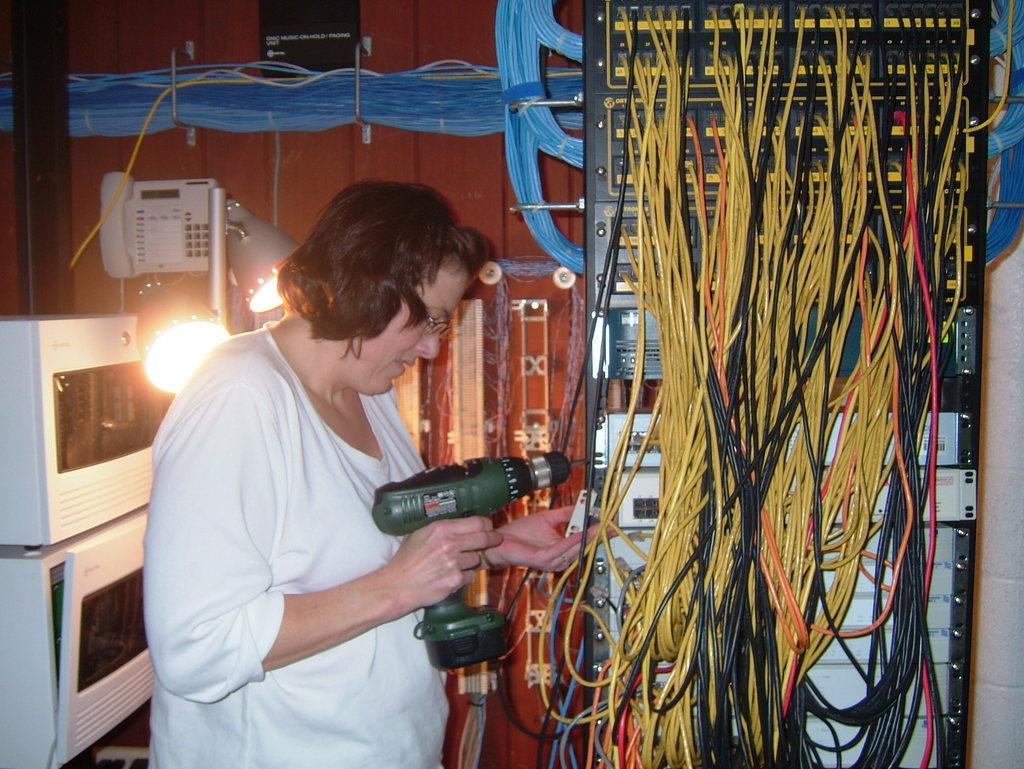Please provide a concise description of this image. This picture shows a woman standing and holding a drilling machine and screwing the screw and we see few electrical boxes and few wires and couple of lights and a telephone on the wall. 